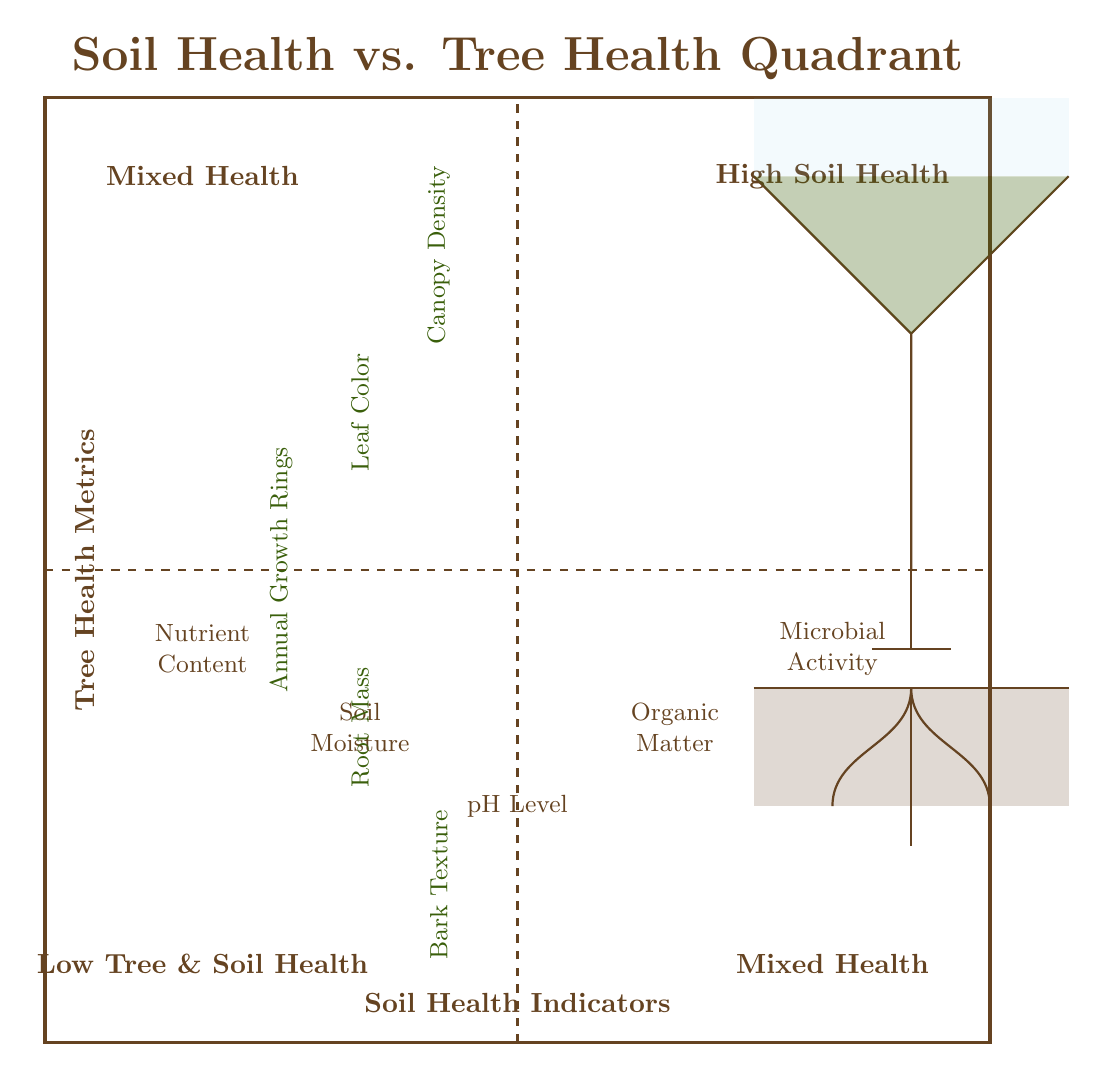What are the indicators located in the Low Tree & Soil Health quadrant? The Low Tree & Soil Health quadrant contains the indicators for Soil Moisture and Root Mass, as they are positioned in the lower-left and lower-right corners of the quadrant respectively.
Answer: Soil Moisture, Root Mass How many Soil Health Indicators are there? The diagram indicates five different Soil Health Indicators that are each labeled within the quadrants.
Answer: Five What Tree Health Metric shows the highest position on the quadrant? Canopy Density is situated at the highest position within the quadrant, noted for its importance in identifying tree health.
Answer: Canopy Density Which quadrant represents High Soil Health? The quadrant located in the upper-right section of the diagram signifies High Soil Health, as indicated by its label.
Answer: High Soil Health Which Soil Health Indicator corresponds with the Tree Health Metric of Bark Texture? The Root Mass, located in the lower-right section, is the Soil Health Indicator associated with Bark Texture, as they are in adjacent quadrants implying mixed health.
Answer: Root Mass What is the relationship between Nutrient Content and Leaf Color? Nutrient Content, found in the Mixed Health quadrant, is correlated with Leaf Color, also in Mixed Health, indicating a potential relationship of influence on tree vitality.
Answer: Correlation Which quadrant contains both Microbial Activity and Canopy Density? The Mixed Health quadrant encompasses both Microbial Activity and Canopy Density, as they are both positioned within this section.
Answer: Mixed Health How many quadrants are present in the diagram? The diagram distinctly shows four quadrants that provide a visual method to categorize the relationship between soil health and tree health metrics.
Answer: Four What does pH Level indicate about soil? pH Level indicates the acidity or alkalinity of the soil, which affects the availability of nutrients essential for tree health.
Answer: Acidity or alkalinity 